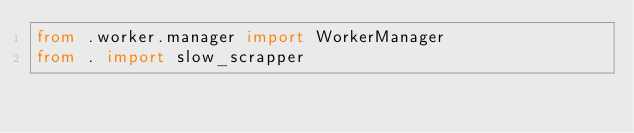Convert code to text. <code><loc_0><loc_0><loc_500><loc_500><_Python_>from .worker.manager import WorkerManager
from . import slow_scrapper</code> 